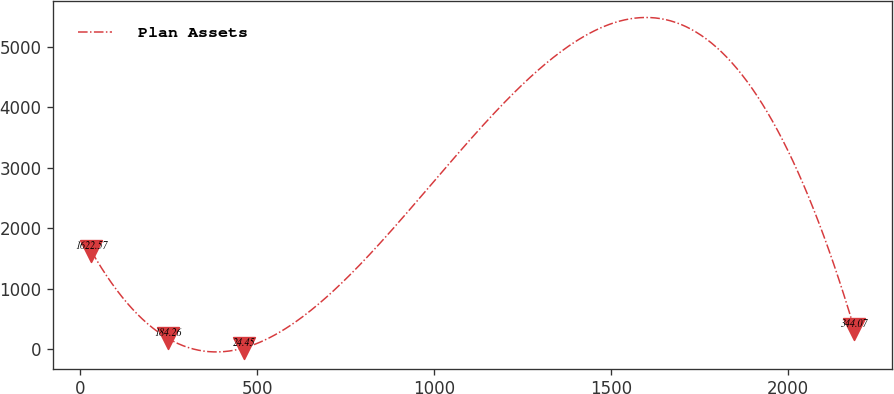Convert chart. <chart><loc_0><loc_0><loc_500><loc_500><line_chart><ecel><fcel>Plan Assets<nl><fcel>30.94<fcel>1622.57<nl><fcel>246.65<fcel>184.26<nl><fcel>462.36<fcel>24.45<nl><fcel>2188.02<fcel>344.07<nl></chart> 